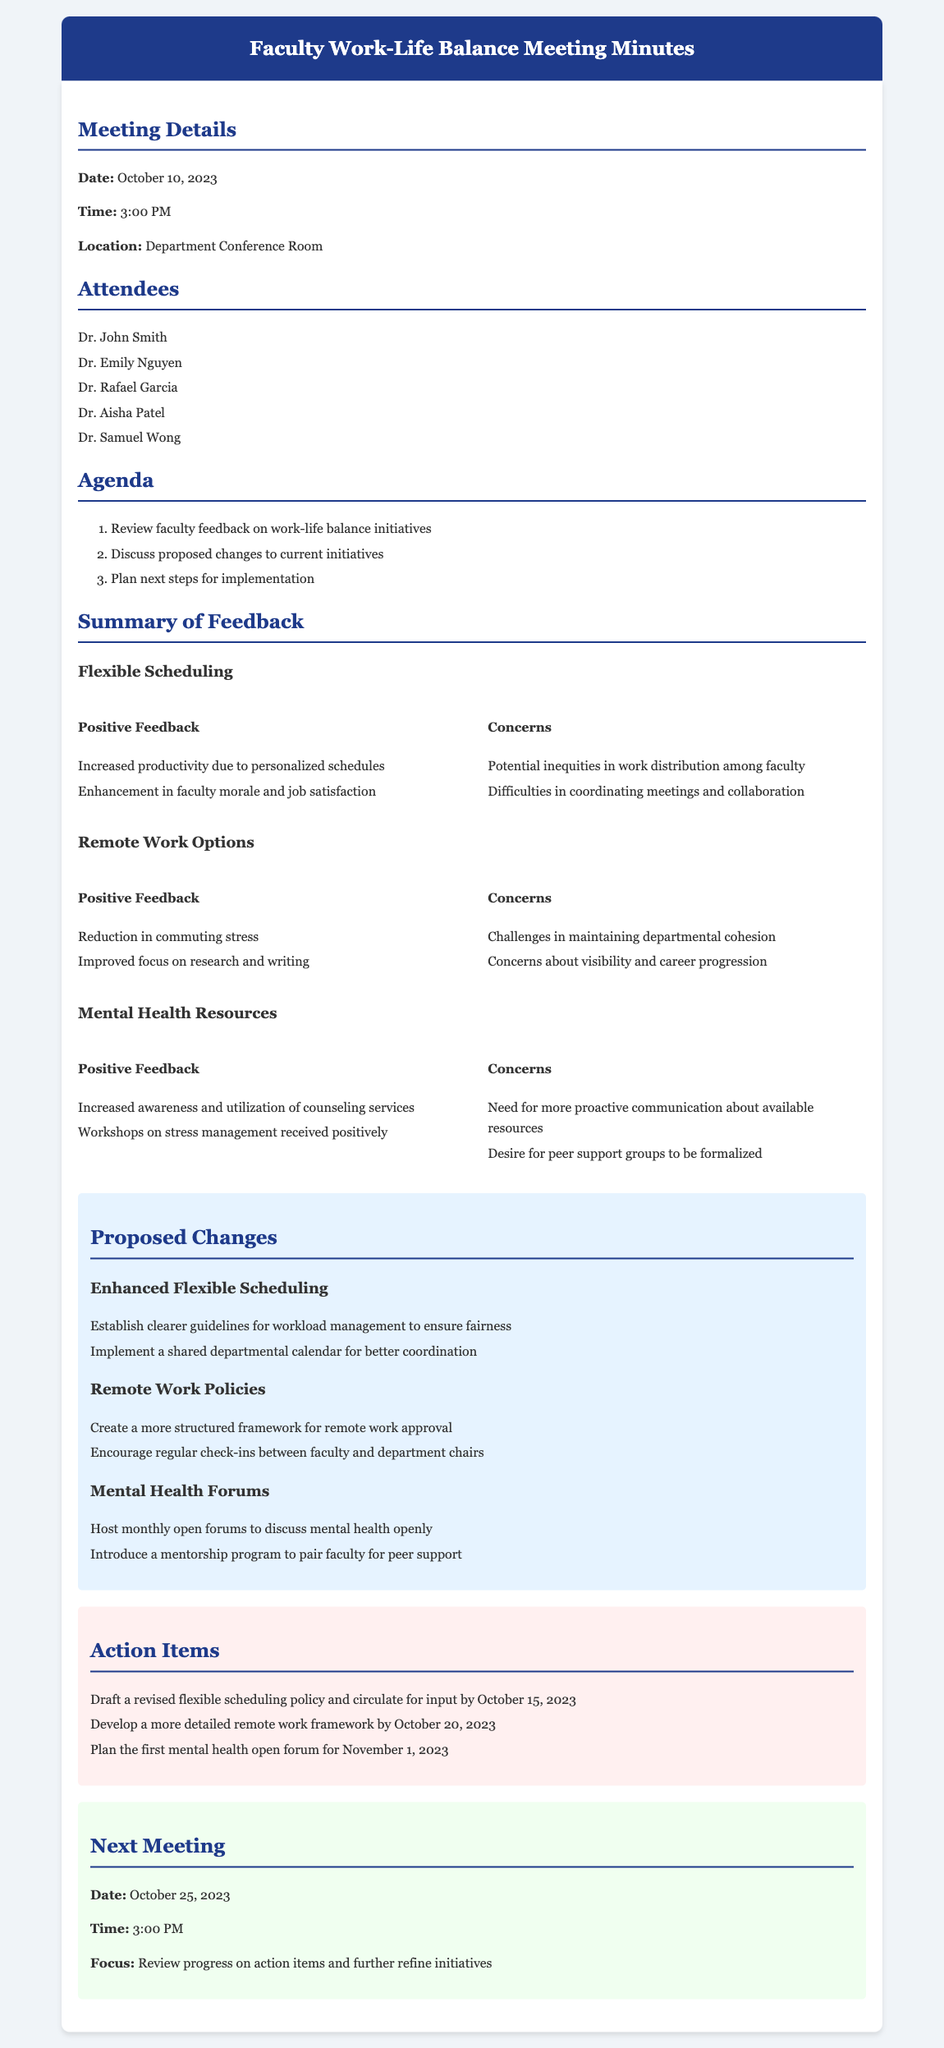what date was the meeting held? The date of the meeting is specified in the Meeting Details section.
Answer: October 10, 2023 who was the first attendee listed? The first attendee can be found in the Attendees section of the document.
Answer: Dr. John Smith what was one of the positive feedbacks regarding flexible scheduling? This information is available in the Summary of Feedback section under Flexible Scheduling.
Answer: Increased productivity due to personalized schedules what is the proposed change for mental health forums? The proposed changes are detailed in the Proposed Changes section of the document.
Answer: Host monthly open forums to discuss mental health openly when is the next meeting scheduled? The next meeting date is found in the Next Meeting section of the document.
Answer: October 25, 2023 what is one concern related to remote work options? The concerns are outlined in the Summary of Feedback section under Remote Work Options.
Answer: Challenges in maintaining departmental cohesion what is one action item to be completed by October 20, 2023? The action items are listed in the Action Items section of the document.
Answer: Develop a more detailed remote work framework by October 20, 2023 which initiative received positive feedback about stress management workshops? This feedback can be found in the Summary of Feedback section under Mental Health Resources.
Answer: Mental Health Resources what is the main focus for the next meeting? This information is stated in the Next Meeting section.
Answer: Review progress on action items and further refine initiatives 